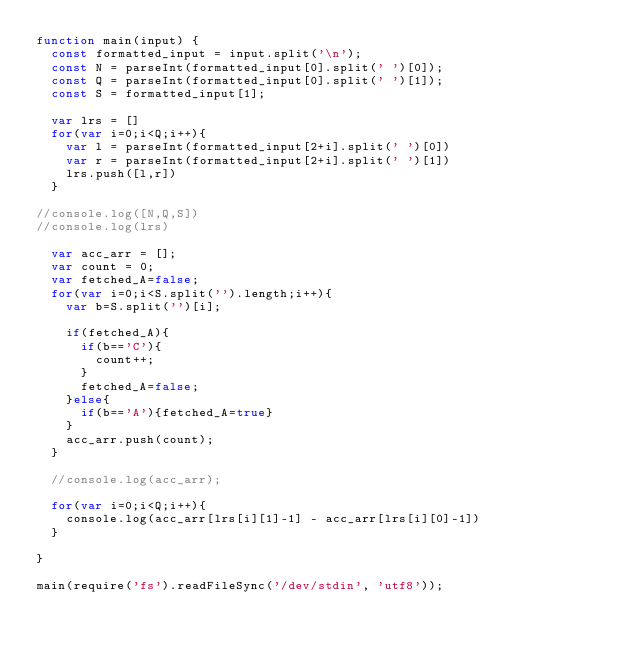Convert code to text. <code><loc_0><loc_0><loc_500><loc_500><_JavaScript_>function main(input) {
  const formatted_input = input.split('\n');
  const N = parseInt(formatted_input[0].split(' ')[0]);
  const Q = parseInt(formatted_input[0].split(' ')[1]);
  const S = formatted_input[1];

  var lrs = []
  for(var i=0;i<Q;i++){
    var l = parseInt(formatted_input[2+i].split(' ')[0])
    var r = parseInt(formatted_input[2+i].split(' ')[1])
    lrs.push([l,r])
  }

//console.log([N,Q,S])
//console.log(lrs)

  var acc_arr = [];
  var count = 0;
  var fetched_A=false;
  for(var i=0;i<S.split('').length;i++){
    var b=S.split('')[i];
    
    if(fetched_A){
      if(b=='C'){
        count++;
      }
      fetched_A=false;
    }else{
      if(b=='A'){fetched_A=true}
    }
    acc_arr.push(count);
  }

  //console.log(acc_arr);

  for(var i=0;i<Q;i++){
    console.log(acc_arr[lrs[i][1]-1] - acc_arr[lrs[i][0]-1])
  }

}

main(require('fs').readFileSync('/dev/stdin', 'utf8'));
</code> 